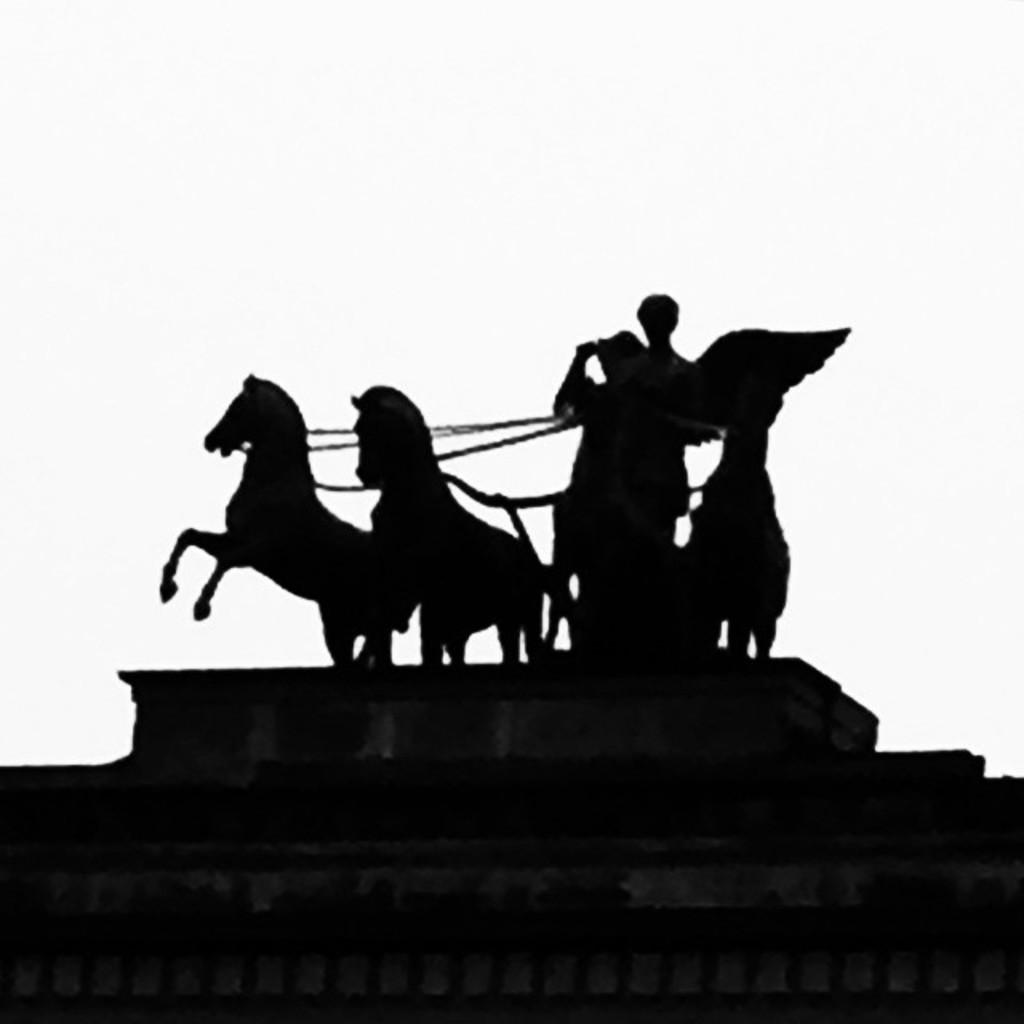What is the main subject of the image? There is a black statue in the image. What color is the background of the image? The background of the image is white. How many giants are present in the image? There are no giants present in the image; it features a black statue. What type of doll can be seen in the image? There is no doll present in the image. 